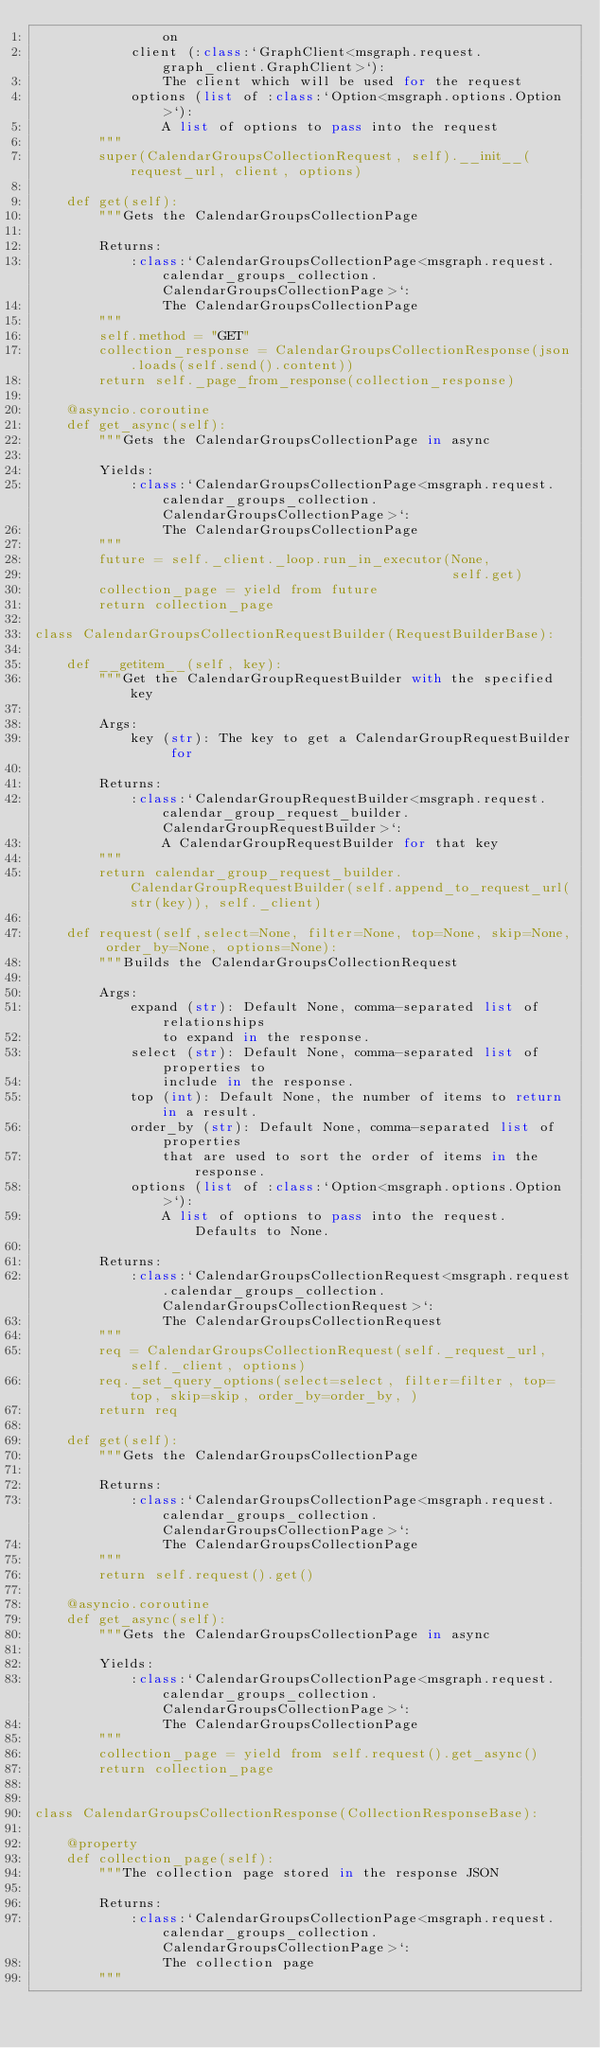<code> <loc_0><loc_0><loc_500><loc_500><_Python_>                on
            client (:class:`GraphClient<msgraph.request.graph_client.GraphClient>`):
                The client which will be used for the request
            options (list of :class:`Option<msgraph.options.Option>`):
                A list of options to pass into the request
        """
        super(CalendarGroupsCollectionRequest, self).__init__(request_url, client, options)

    def get(self):
        """Gets the CalendarGroupsCollectionPage

        Returns: 
            :class:`CalendarGroupsCollectionPage<msgraph.request.calendar_groups_collection.CalendarGroupsCollectionPage>`:
                The CalendarGroupsCollectionPage
        """
        self.method = "GET"
        collection_response = CalendarGroupsCollectionResponse(json.loads(self.send().content))
        return self._page_from_response(collection_response)

    @asyncio.coroutine
    def get_async(self):
        """Gets the CalendarGroupsCollectionPage in async

        Yields: 
            :class:`CalendarGroupsCollectionPage<msgraph.request.calendar_groups_collection.CalendarGroupsCollectionPage>`:
                The CalendarGroupsCollectionPage
        """
        future = self._client._loop.run_in_executor(None,
                                                    self.get)
        collection_page = yield from future
        return collection_page

class CalendarGroupsCollectionRequestBuilder(RequestBuilderBase):

    def __getitem__(self, key):
        """Get the CalendarGroupRequestBuilder with the specified key
        
        Args:
            key (str): The key to get a CalendarGroupRequestBuilder for
        
        Returns: 
            :class:`CalendarGroupRequestBuilder<msgraph.request.calendar_group_request_builder.CalendarGroupRequestBuilder>`:
                A CalendarGroupRequestBuilder for that key
        """
        return calendar_group_request_builder.CalendarGroupRequestBuilder(self.append_to_request_url(str(key)), self._client)

    def request(self,select=None, filter=None, top=None, skip=None, order_by=None, options=None):
        """Builds the CalendarGroupsCollectionRequest
        
        Args:
            expand (str): Default None, comma-separated list of relationships
                to expand in the response.
            select (str): Default None, comma-separated list of properties to
                include in the response.
            top (int): Default None, the number of items to return in a result.
            order_by (str): Default None, comma-separated list of properties
                that are used to sort the order of items in the response.
            options (list of :class:`Option<msgraph.options.Option>`):
                A list of options to pass into the request. Defaults to None.

        Returns:
            :class:`CalendarGroupsCollectionRequest<msgraph.request.calendar_groups_collection.CalendarGroupsCollectionRequest>`:
                The CalendarGroupsCollectionRequest
        """
        req = CalendarGroupsCollectionRequest(self._request_url, self._client, options)
        req._set_query_options(select=select, filter=filter, top=top, skip=skip, order_by=order_by, )
        return req

    def get(self):
        """Gets the CalendarGroupsCollectionPage

        Returns: 
            :class:`CalendarGroupsCollectionPage<msgraph.request.calendar_groups_collection.CalendarGroupsCollectionPage>`:
                The CalendarGroupsCollectionPage
        """
        return self.request().get()

    @asyncio.coroutine
    def get_async(self):
        """Gets the CalendarGroupsCollectionPage in async

        Yields: 
            :class:`CalendarGroupsCollectionPage<msgraph.request.calendar_groups_collection.CalendarGroupsCollectionPage>`:
                The CalendarGroupsCollectionPage
        """
        collection_page = yield from self.request().get_async()
        return collection_page


class CalendarGroupsCollectionResponse(CollectionResponseBase):

    @property
    def collection_page(self):
        """The collection page stored in the response JSON
        
        Returns:
            :class:`CalendarGroupsCollectionPage<msgraph.request.calendar_groups_collection.CalendarGroupsCollectionPage>`:
                The collection page
        """</code> 